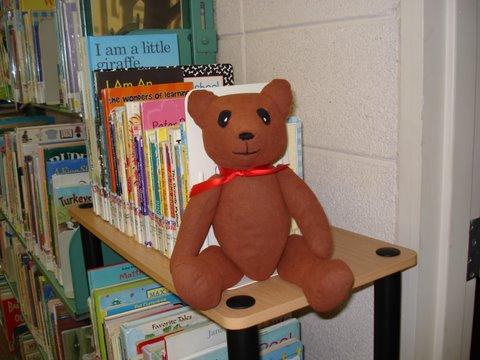What color is the bear's bow?
Be succinct. Red. What sort of room is this?
Give a very brief answer. Library. Is this a real bear?
Give a very brief answer. No. 